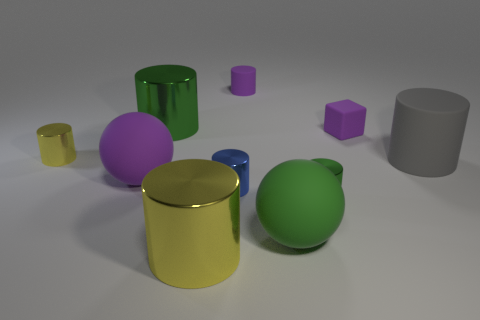Subtract all tiny rubber cylinders. How many cylinders are left? 6 Subtract 2 cylinders. How many cylinders are left? 5 Subtract all blue cylinders. How many cylinders are left? 6 Add 8 red shiny cubes. How many red shiny cubes exist? 8 Subtract 1 yellow cylinders. How many objects are left? 9 Subtract all cylinders. How many objects are left? 3 Subtract all green blocks. Subtract all gray spheres. How many blocks are left? 1 Subtract all cyan cubes. How many cyan balls are left? 0 Subtract all small purple things. Subtract all tiny red objects. How many objects are left? 8 Add 3 big green objects. How many big green objects are left? 5 